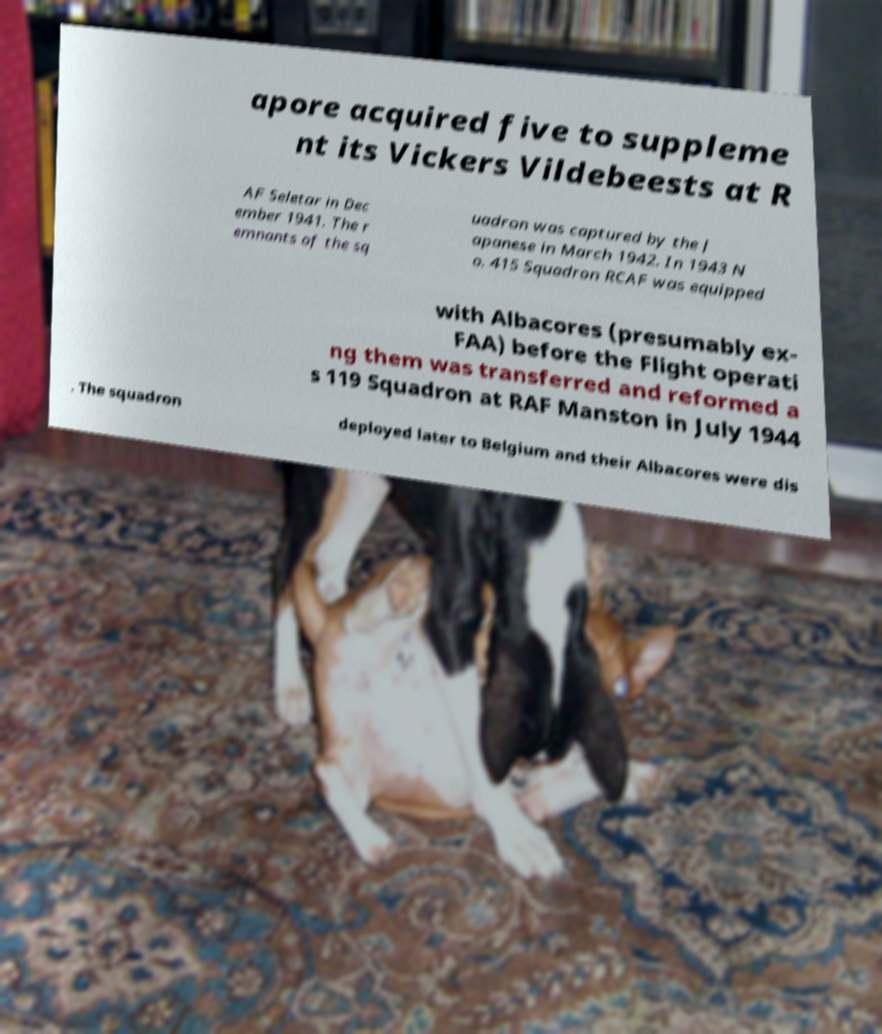Could you extract and type out the text from this image? apore acquired five to suppleme nt its Vickers Vildebeests at R AF Seletar in Dec ember 1941. The r emnants of the sq uadron was captured by the J apanese in March 1942. In 1943 N o. 415 Squadron RCAF was equipped with Albacores (presumably ex- FAA) before the Flight operati ng them was transferred and reformed a s 119 Squadron at RAF Manston in July 1944 . The squadron deployed later to Belgium and their Albacores were dis 